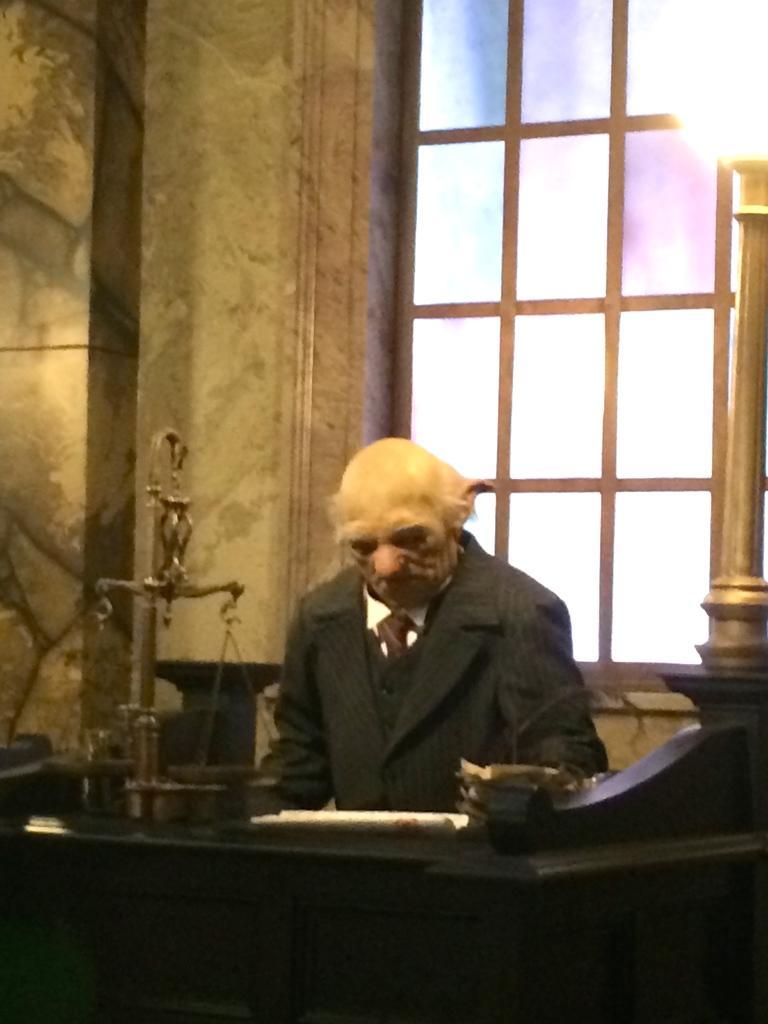In one or two sentences, can you explain what this image depicts? There is a person in black color suit, sitting on a chair and reading a book. In front of him, there is a balance on the table. In the background, there is a glass window near wall. 